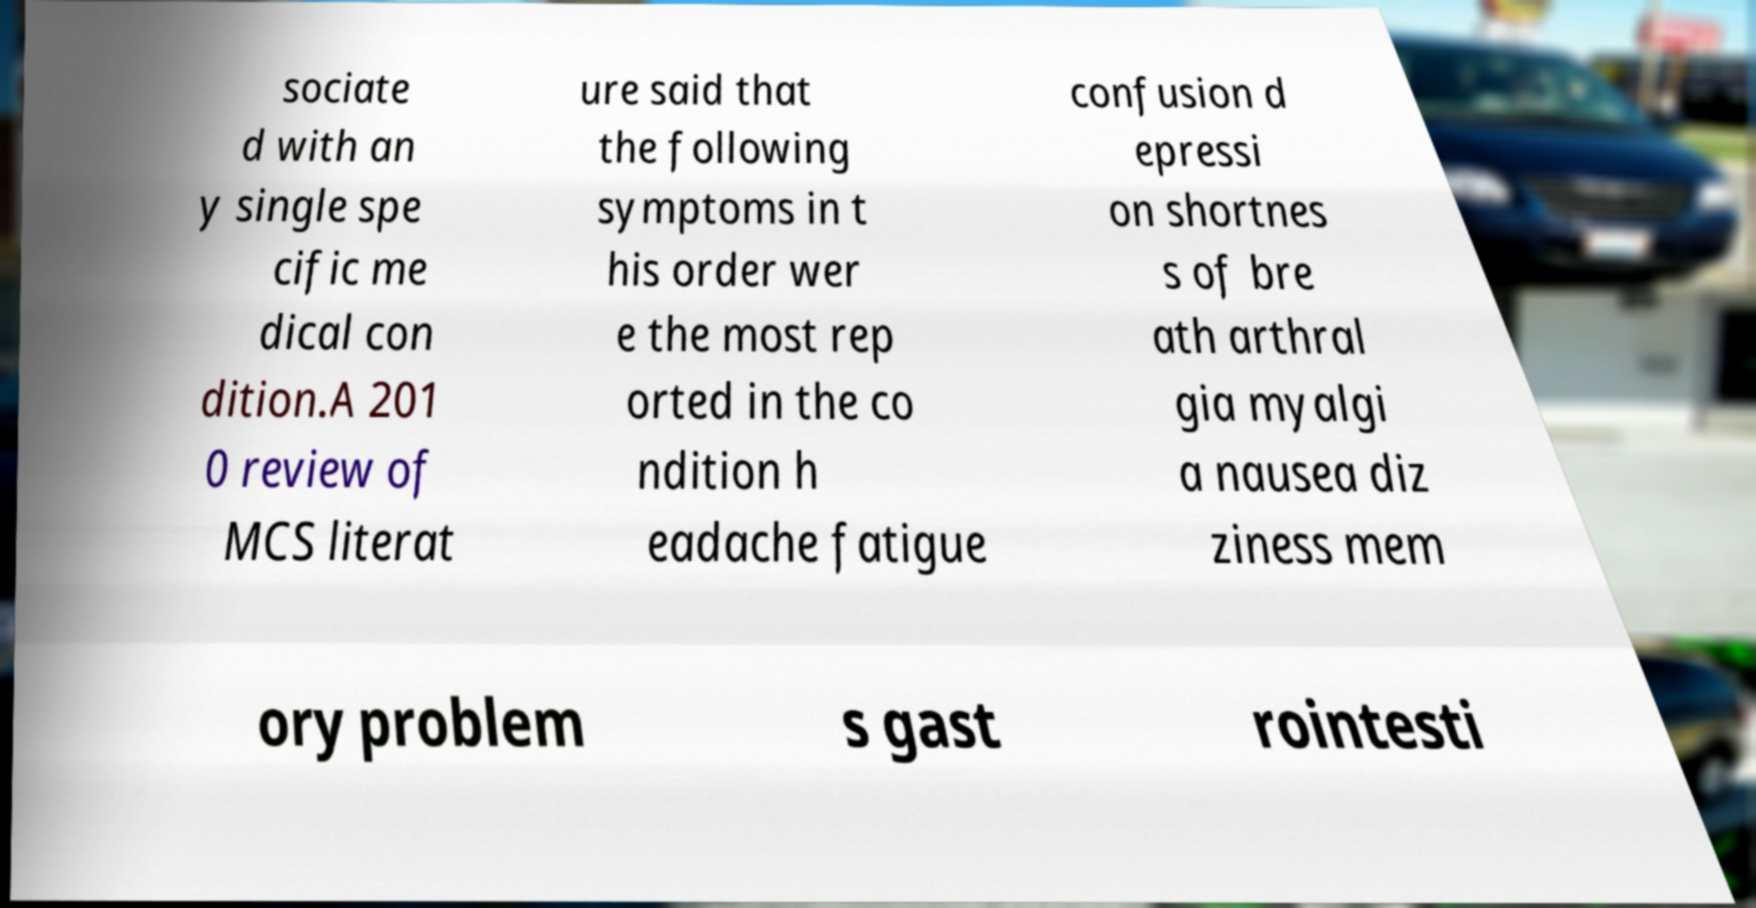Can you accurately transcribe the text from the provided image for me? sociate d with an y single spe cific me dical con dition.A 201 0 review of MCS literat ure said that the following symptoms in t his order wer e the most rep orted in the co ndition h eadache fatigue confusion d epressi on shortnes s of bre ath arthral gia myalgi a nausea diz ziness mem ory problem s gast rointesti 